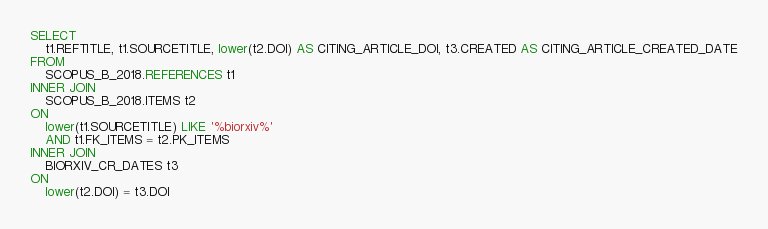Convert code to text. <code><loc_0><loc_0><loc_500><loc_500><_SQL_>SELECT
    t1.REFTITLE, t1.SOURCETITLE, lower(t2.DOI) AS CITING_ARTICLE_DOI, t3.CREATED AS CITING_ARTICLE_CREATED_DATE
FROM
    SCOPUS_B_2018.REFERENCES t1
INNER JOIN
    SCOPUS_B_2018.ITEMS t2
ON
    lower(t1.SOURCETITLE) LIKE '%biorxiv%'
    AND t1.FK_ITEMS = t2.PK_ITEMS
INNER JOIN
    BIORXIV_CR_DATES t3
ON
    lower(t2.DOI) = t3.DOI</code> 